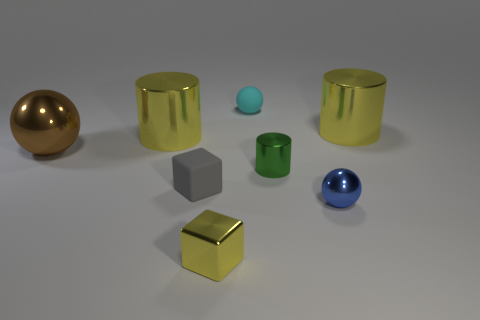Is there a pattern to the arrangement of the objects? The objects are arranged with no apparent pattern in terms of shape, size, or material properties. They are dispersed across the surface in a seemingly random configuration, which gives the scene a casual and unstructured feel, rather than a deliberate or methodical layout. 